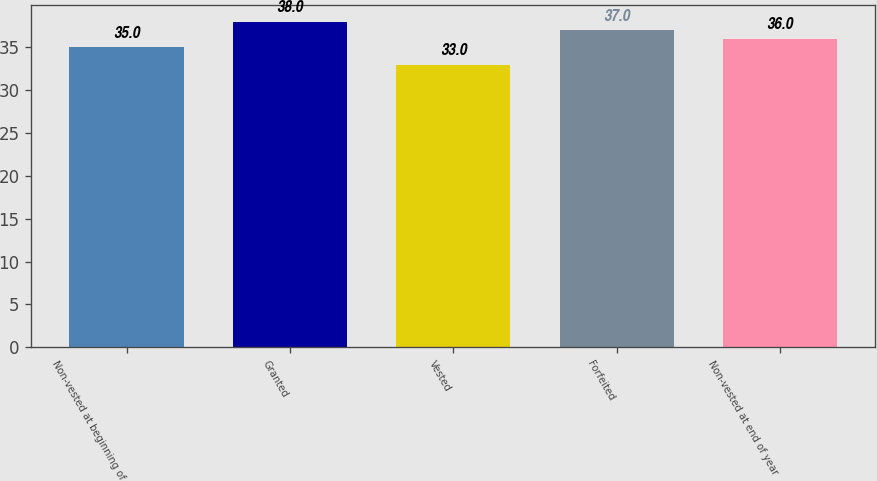<chart> <loc_0><loc_0><loc_500><loc_500><bar_chart><fcel>Non-vested at beginning of<fcel>Granted<fcel>Vested<fcel>Forfeited<fcel>Non-vested at end of year<nl><fcel>35<fcel>38<fcel>33<fcel>37<fcel>36<nl></chart> 